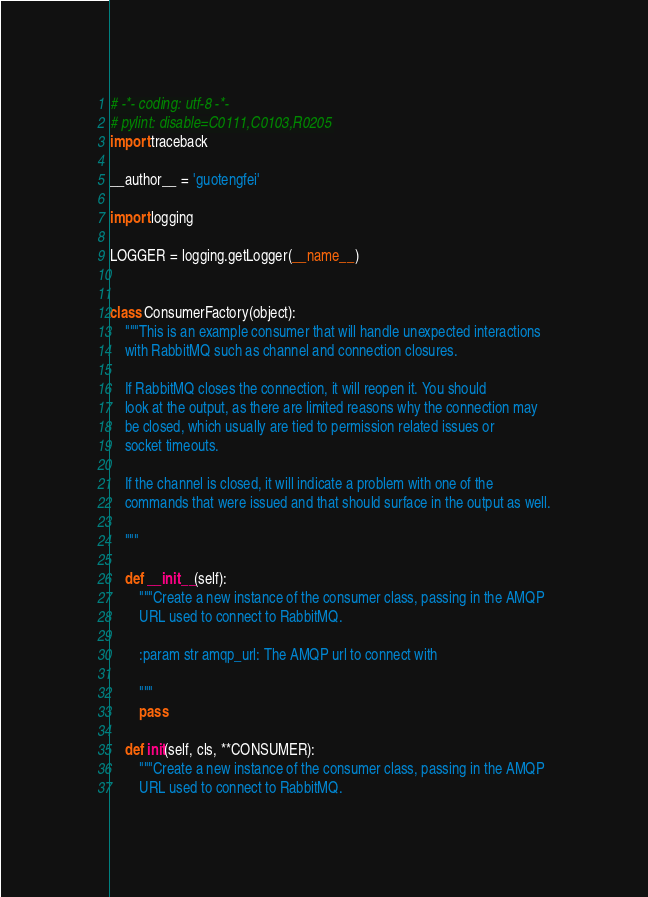<code> <loc_0><loc_0><loc_500><loc_500><_Python_># -*- coding: utf-8 -*-
# pylint: disable=C0111,C0103,R0205
import traceback

__author__ = 'guotengfei'

import logging

LOGGER = logging.getLogger(__name__)


class ConsumerFactory(object):
    """This is an example consumer that will handle unexpected interactions
    with RabbitMQ such as channel and connection closures.

    If RabbitMQ closes the connection, it will reopen it. You should
    look at the output, as there are limited reasons why the connection may
    be closed, which usually are tied to permission related issues or
    socket timeouts.

    If the channel is closed, it will indicate a problem with one of the
    commands that were issued and that should surface in the output as well.

    """

    def __init__(self):
        """Create a new instance of the consumer class, passing in the AMQP
        URL used to connect to RabbitMQ.

        :param str amqp_url: The AMQP url to connect with

        """
        pass

    def init(self, cls, **CONSUMER):
        """Create a new instance of the consumer class, passing in the AMQP
        URL used to connect to RabbitMQ.
</code> 